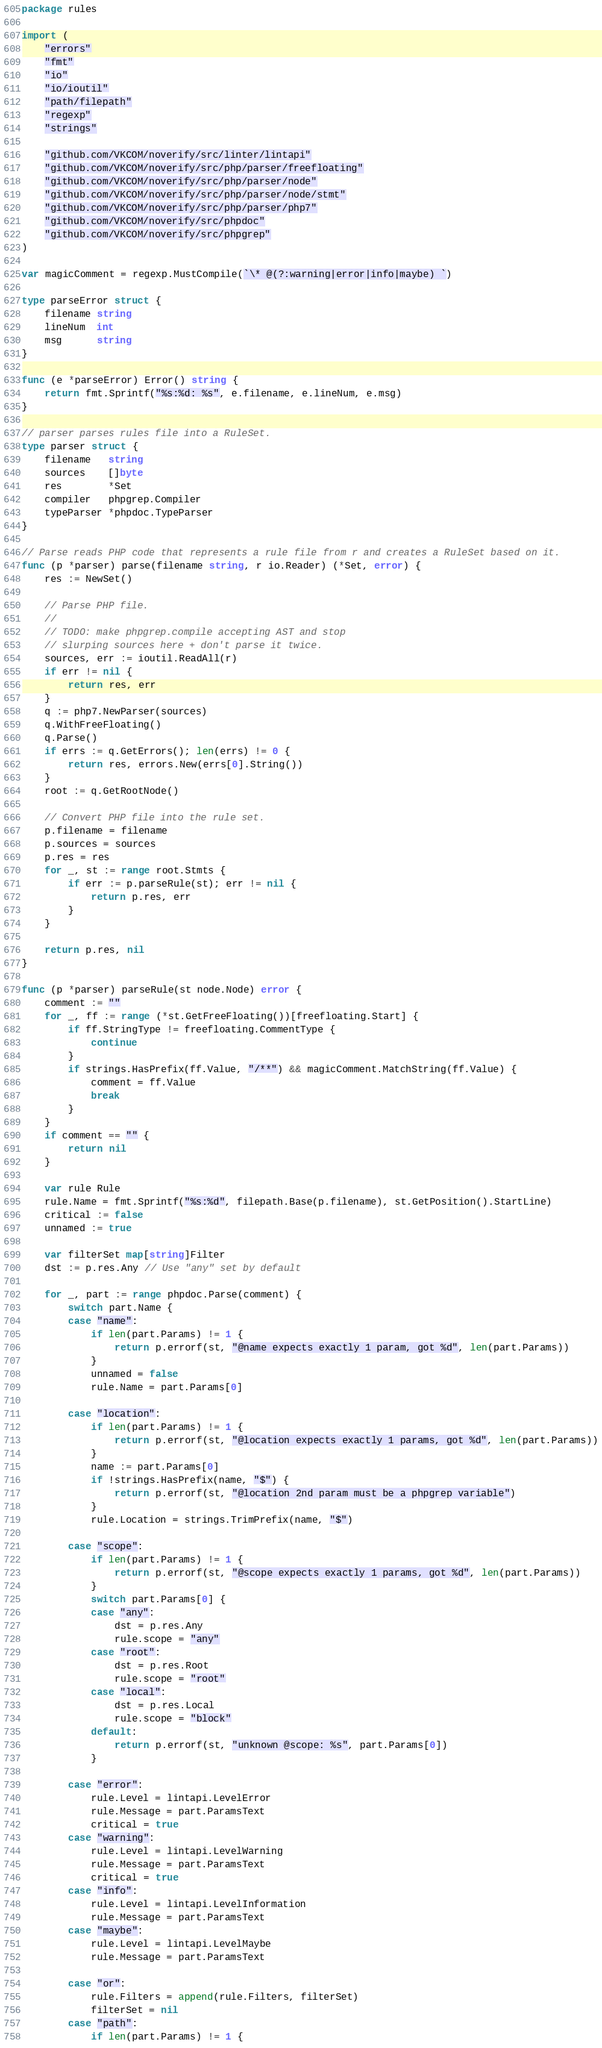<code> <loc_0><loc_0><loc_500><loc_500><_Go_>package rules

import (
	"errors"
	"fmt"
	"io"
	"io/ioutil"
	"path/filepath"
	"regexp"
	"strings"

	"github.com/VKCOM/noverify/src/linter/lintapi"
	"github.com/VKCOM/noverify/src/php/parser/freefloating"
	"github.com/VKCOM/noverify/src/php/parser/node"
	"github.com/VKCOM/noverify/src/php/parser/node/stmt"
	"github.com/VKCOM/noverify/src/php/parser/php7"
	"github.com/VKCOM/noverify/src/phpdoc"
	"github.com/VKCOM/noverify/src/phpgrep"
)

var magicComment = regexp.MustCompile(`\* @(?:warning|error|info|maybe) `)

type parseError struct {
	filename string
	lineNum  int
	msg      string
}

func (e *parseError) Error() string {
	return fmt.Sprintf("%s:%d: %s", e.filename, e.lineNum, e.msg)
}

// parser parses rules file into a RuleSet.
type parser struct {
	filename   string
	sources    []byte
	res        *Set
	compiler   phpgrep.Compiler
	typeParser *phpdoc.TypeParser
}

// Parse reads PHP code that represents a rule file from r and creates a RuleSet based on it.
func (p *parser) parse(filename string, r io.Reader) (*Set, error) {
	res := NewSet()

	// Parse PHP file.
	//
	// TODO: make phpgrep.compile accepting AST and stop
	// slurping sources here + don't parse it twice.
	sources, err := ioutil.ReadAll(r)
	if err != nil {
		return res, err
	}
	q := php7.NewParser(sources)
	q.WithFreeFloating()
	q.Parse()
	if errs := q.GetErrors(); len(errs) != 0 {
		return res, errors.New(errs[0].String())
	}
	root := q.GetRootNode()

	// Convert PHP file into the rule set.
	p.filename = filename
	p.sources = sources
	p.res = res
	for _, st := range root.Stmts {
		if err := p.parseRule(st); err != nil {
			return p.res, err
		}
	}

	return p.res, nil
}

func (p *parser) parseRule(st node.Node) error {
	comment := ""
	for _, ff := range (*st.GetFreeFloating())[freefloating.Start] {
		if ff.StringType != freefloating.CommentType {
			continue
		}
		if strings.HasPrefix(ff.Value, "/**") && magicComment.MatchString(ff.Value) {
			comment = ff.Value
			break
		}
	}
	if comment == "" {
		return nil
	}

	var rule Rule
	rule.Name = fmt.Sprintf("%s:%d", filepath.Base(p.filename), st.GetPosition().StartLine)
	critical := false
	unnamed := true

	var filterSet map[string]Filter
	dst := p.res.Any // Use "any" set by default

	for _, part := range phpdoc.Parse(comment) {
		switch part.Name {
		case "name":
			if len(part.Params) != 1 {
				return p.errorf(st, "@name expects exactly 1 param, got %d", len(part.Params))
			}
			unnamed = false
			rule.Name = part.Params[0]

		case "location":
			if len(part.Params) != 1 {
				return p.errorf(st, "@location expects exactly 1 params, got %d", len(part.Params))
			}
			name := part.Params[0]
			if !strings.HasPrefix(name, "$") {
				return p.errorf(st, "@location 2nd param must be a phpgrep variable")
			}
			rule.Location = strings.TrimPrefix(name, "$")

		case "scope":
			if len(part.Params) != 1 {
				return p.errorf(st, "@scope expects exactly 1 params, got %d", len(part.Params))
			}
			switch part.Params[0] {
			case "any":
				dst = p.res.Any
				rule.scope = "any"
			case "root":
				dst = p.res.Root
				rule.scope = "root"
			case "local":
				dst = p.res.Local
				rule.scope = "block"
			default:
				return p.errorf(st, "unknown @scope: %s", part.Params[0])
			}

		case "error":
			rule.Level = lintapi.LevelError
			rule.Message = part.ParamsText
			critical = true
		case "warning":
			rule.Level = lintapi.LevelWarning
			rule.Message = part.ParamsText
			critical = true
		case "info":
			rule.Level = lintapi.LevelInformation
			rule.Message = part.ParamsText
		case "maybe":
			rule.Level = lintapi.LevelMaybe
			rule.Message = part.ParamsText

		case "or":
			rule.Filters = append(rule.Filters, filterSet)
			filterSet = nil
		case "path":
			if len(part.Params) != 1 {</code> 